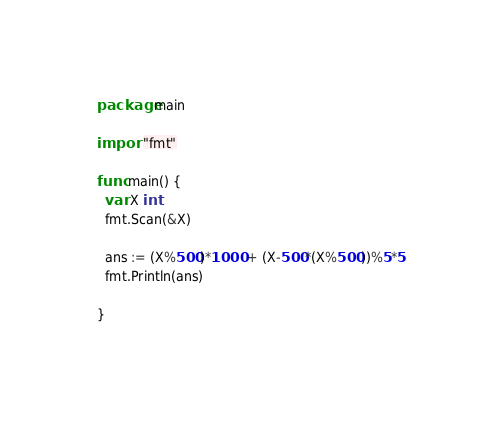Convert code to text. <code><loc_0><loc_0><loc_500><loc_500><_Go_>package main

import "fmt"

func main() {
  var X int
  fmt.Scan(&X)
  
  ans := (X%500)*1000 + (X-500*(X%500))%5*5
  fmt.Println(ans)
 
}</code> 